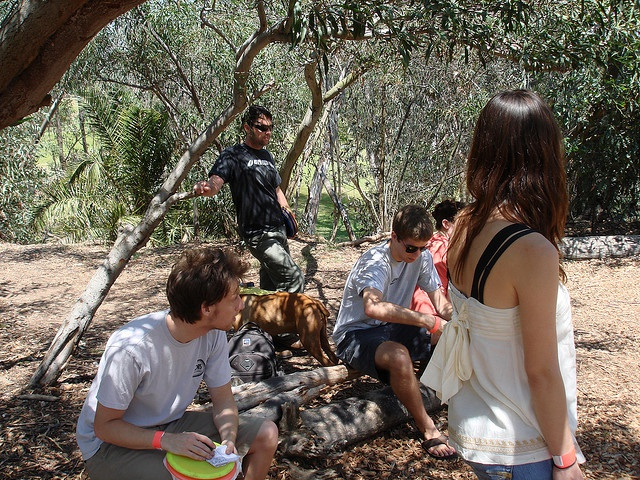Describe the objects in this image and their specific colors. I can see people in darkgreen, black, darkgray, and gray tones, people in darkgreen, gray, and black tones, people in darkgreen, black, gray, maroon, and darkgray tones, people in darkgreen, black, gray, darkgray, and maroon tones, and dog in darkgreen, black, maroon, and gray tones in this image. 